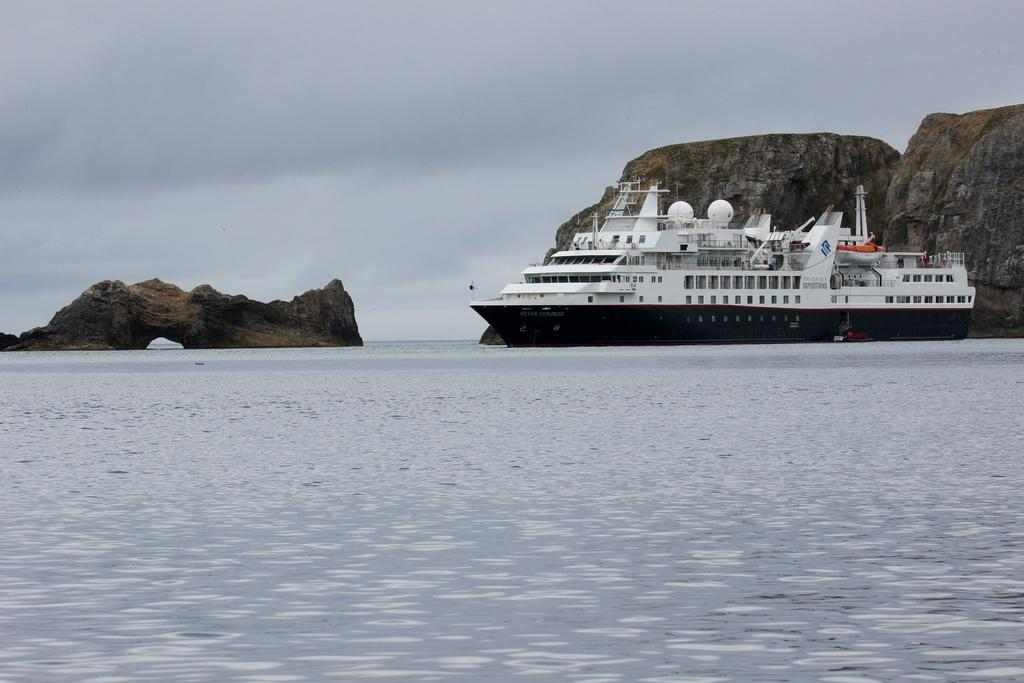What is at the bottom of the image? There is water at the bottom of the image. What is in the water? There is a ship in the water. What can be seen in the background of the image? There are hills visible in the background of the image. What is visible at the top of the image? The sky is visible at the top of the image. What type of card is being used to navigate the ship in the image? There is no card present in the image, and the ship's navigation is not depicted. What material is the ship made of in the image? The material the ship is made of is not mentioned in the image. 